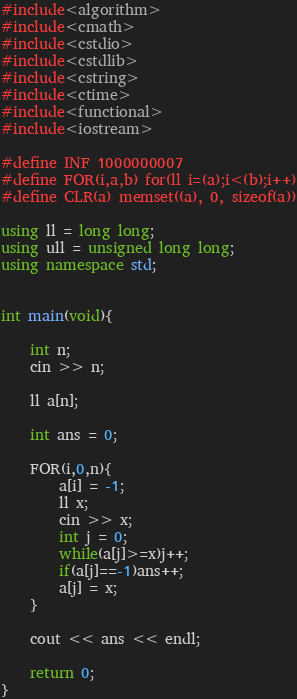<code> <loc_0><loc_0><loc_500><loc_500><_C++_>#include<algorithm>
#include<cmath>
#include<cstdio>
#include<cstdlib>
#include<cstring>
#include<ctime>
#include<functional>
#include<iostream>

#define INF 1000000007
#define FOR(i,a,b) for(ll i=(a);i<(b);i++)
#define CLR(a) memset((a), 0, sizeof(a))

using ll = long long;
using ull = unsigned long long;
using namespace std;


int main(void){

    int n;
    cin >> n;

    ll a[n];

    int ans = 0;

    FOR(i,0,n){
        a[i] = -1;
        ll x;
        cin >> x;
        int j = 0;
        while(a[j]>=x)j++;
        if(a[j]==-1)ans++;
        a[j] = x;
    }

    cout << ans << endl;

    return 0;
}
</code> 